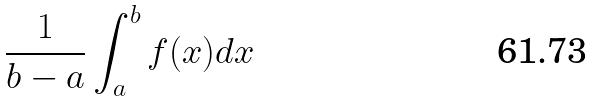<formula> <loc_0><loc_0><loc_500><loc_500>\frac { 1 } { b - a } \int _ { a } ^ { b } f ( x ) d x</formula> 